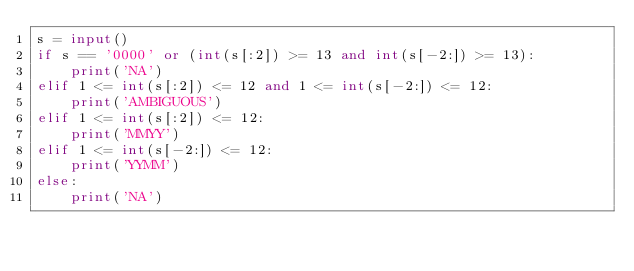<code> <loc_0><loc_0><loc_500><loc_500><_Python_>s = input()
if s == '0000' or (int(s[:2]) >= 13 and int(s[-2:]) >= 13):
    print('NA')
elif 1 <= int(s[:2]) <= 12 and 1 <= int(s[-2:]) <= 12:
    print('AMBIGUOUS')
elif 1 <= int(s[:2]) <= 12:
    print('MMYY')
elif 1 <= int(s[-2:]) <= 12:
    print('YYMM')
else:
    print('NA')</code> 